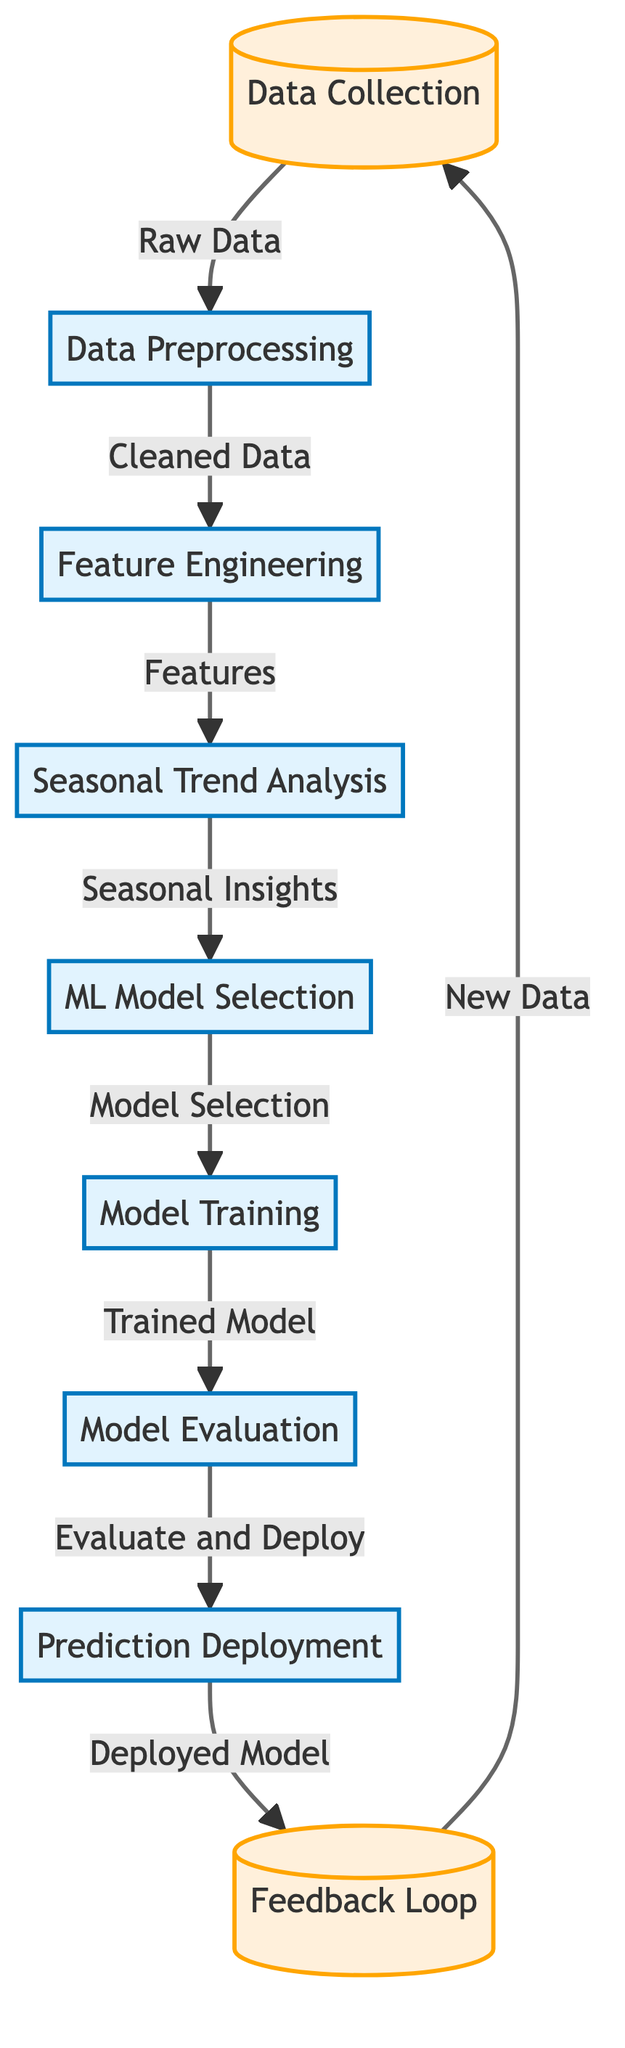What is the first node in the diagram? The first node in the diagram represents the process of "Data Collection," which is where the entire flow begins.
Answer: Data Collection How many process nodes are there in the diagram? By counting the nodes classified as "process," we find a total of six such nodes, which includes all the steps related to processing and analyzing data.
Answer: 6 What type of data is generated after the "Data Preprocessing" step? The output of the "Data Preprocessing" node is "Cleaned Data," indicating that the data has been refined for further analysis.
Answer: Cleaned Data Which node follows the "Seasonal Trend Analysis"? After "Seasonal Trend Analysis," the next step is "ML Model Selection," indicating the sequence from analyzing trends to choosing an appropriate machine learning model.
Answer: ML Model Selection What do the links in the diagram represent? The links in the diagram represent the flow of data and the sequence of processes from one step to another in the machine learning workflow.
Answer: Flow of Data How does the "Feedback Loop" relate to the "Data Collection"? The "Feedback Loop" provides new data back to the "Data Collection," creating a cycle that allows the system to continuously improve by incorporating fresh insights gained from the deployed model.
Answer: New Data Which process is responsible for creating features from the cleaned data? The "Feature Engineering" process creates features from the cleaned data, preparing it further for model selection and training.
Answer: Feature Engineering What is the output of the "Model Evaluation"? The output of the "Model Evaluation" is "Evaluate and Deploy," meaning once the model is evaluated, it prepares for deployment.
Answer: Evaluate and Deploy What is the end result of the entire process depicted in the diagram? The end result of the entire process is the "Deployed Model," which signifies that the machine learning model is now in operation based on prior steps.
Answer: Deployed Model 